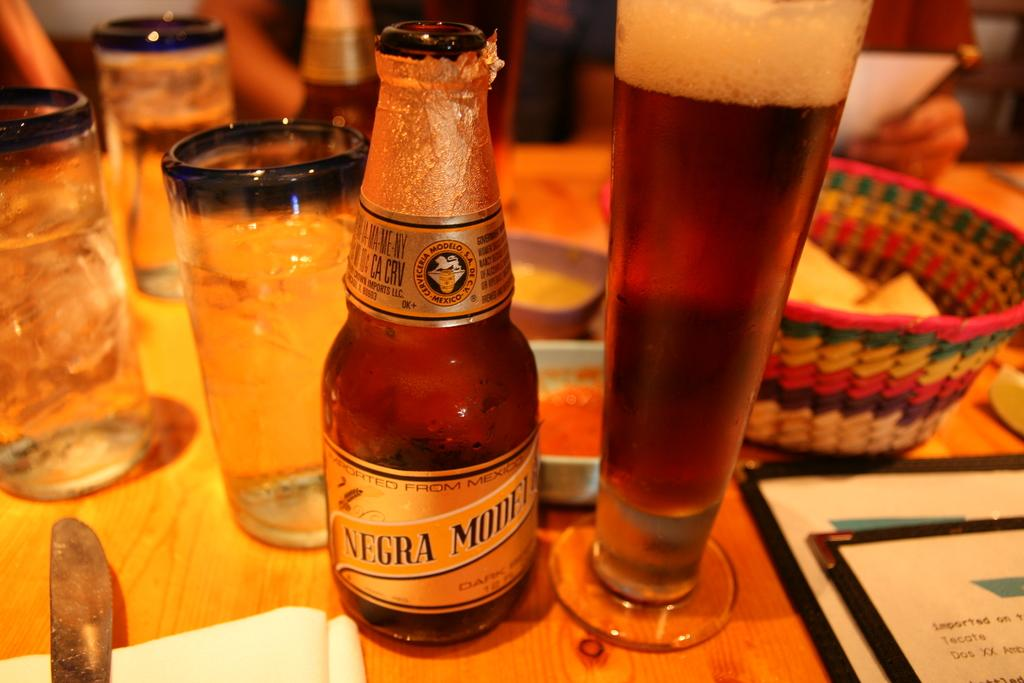Provide a one-sentence caption for the provided image. A bottle of Negra Modela sits next to a full glass of beer on a wood table. 